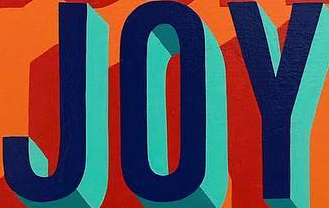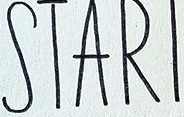What words are shown in these images in order, separated by a semicolon? JOY; STARI 